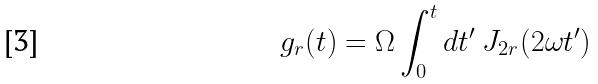<formula> <loc_0><loc_0><loc_500><loc_500>g _ { r } ( t ) = \Omega \int _ { 0 } ^ { t } d t ^ { \prime } \ J _ { 2 r } ( 2 \omega t ^ { \prime } )</formula> 